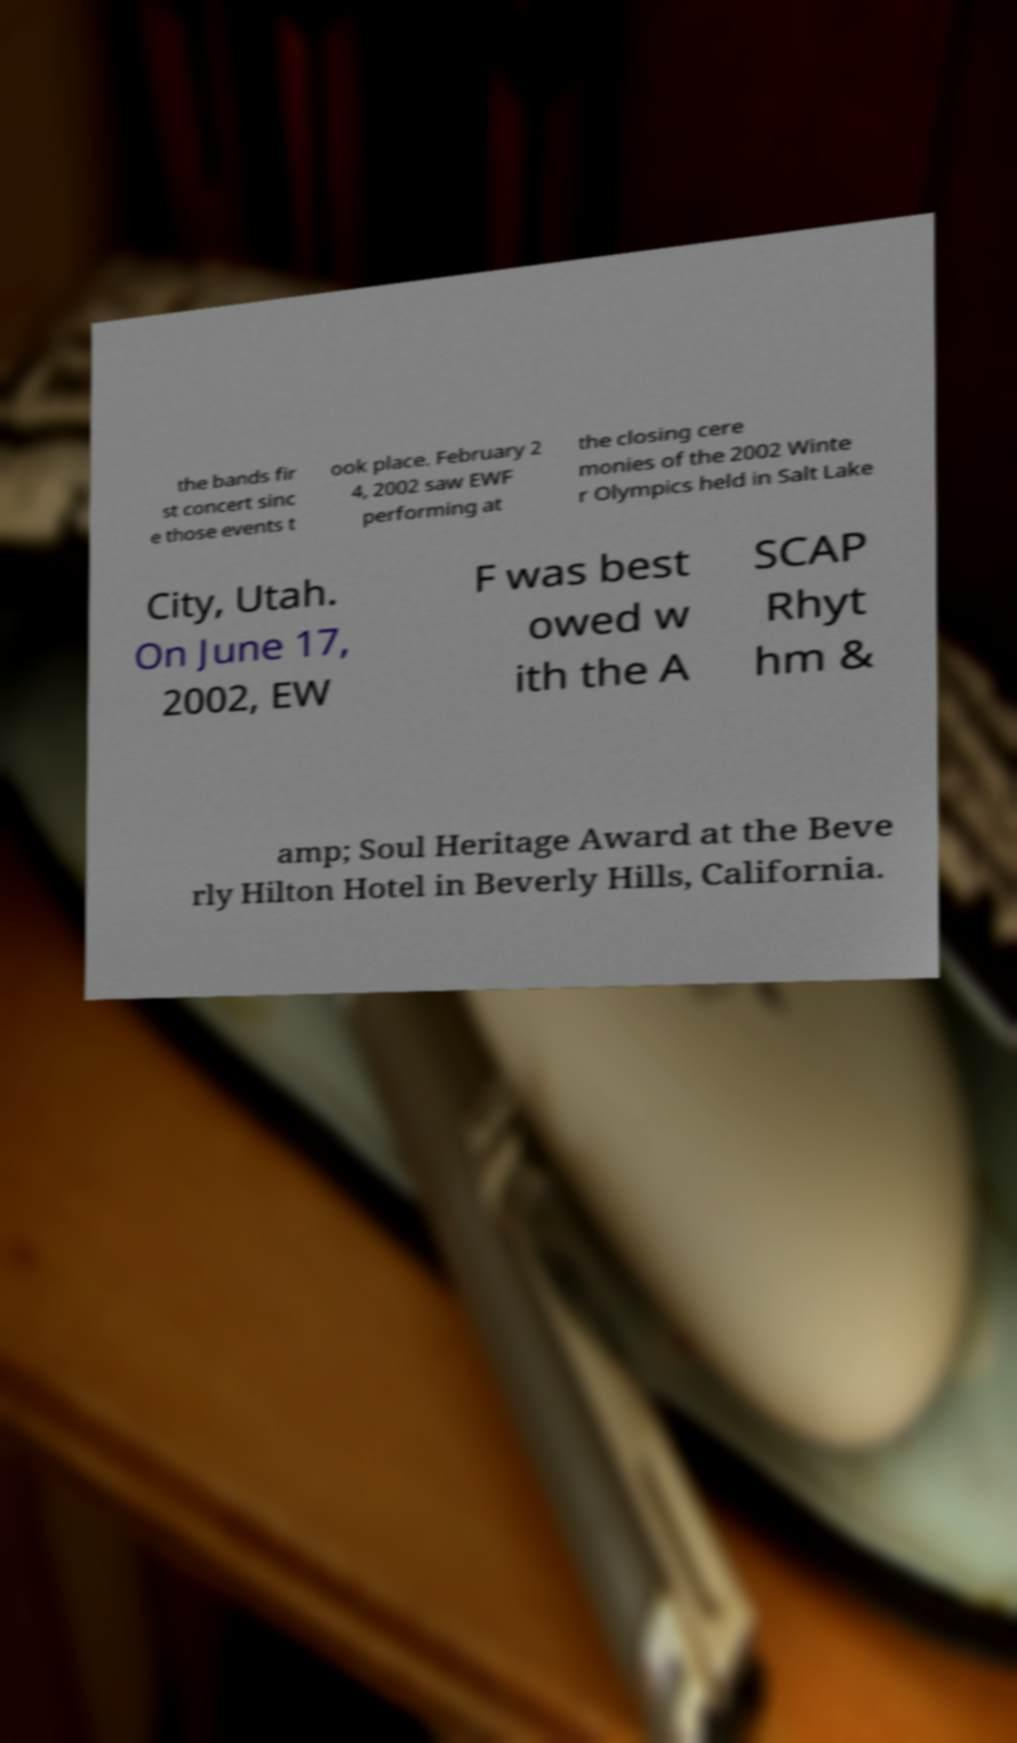Please identify and transcribe the text found in this image. the bands fir st concert sinc e those events t ook place. February 2 4, 2002 saw EWF performing at the closing cere monies of the 2002 Winte r Olympics held in Salt Lake City, Utah. On June 17, 2002, EW F was best owed w ith the A SCAP Rhyt hm & amp; Soul Heritage Award at the Beve rly Hilton Hotel in Beverly Hills, California. 